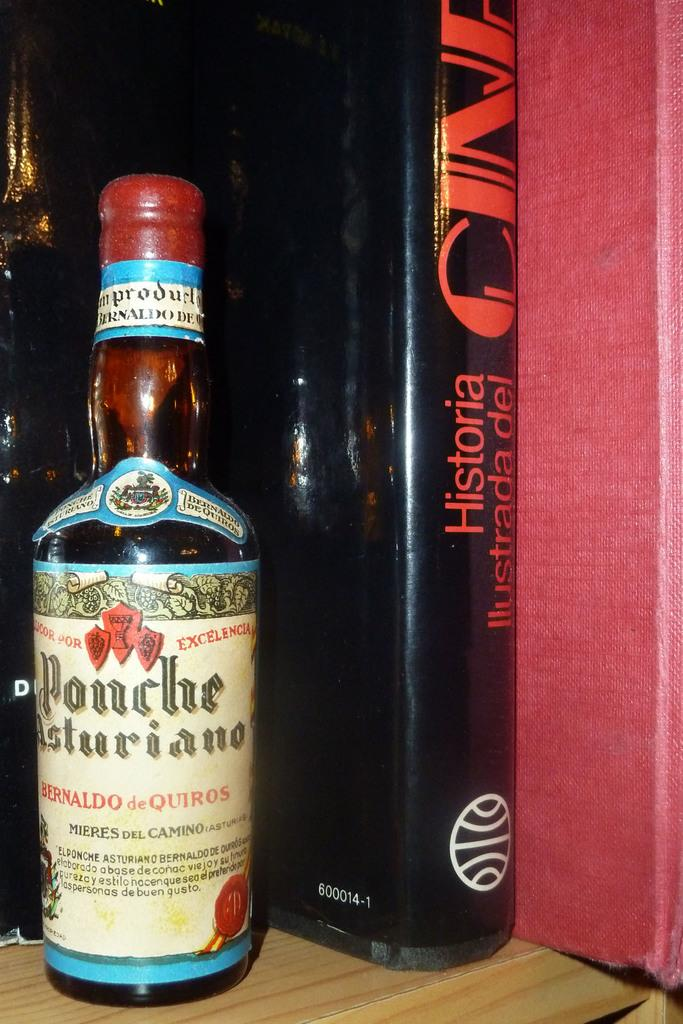<image>
Share a concise interpretation of the image provided. A bottle of Ponche Asturiano liquor is on a shelf next to a hardcover copy of Historia Ilustrada del cine. 